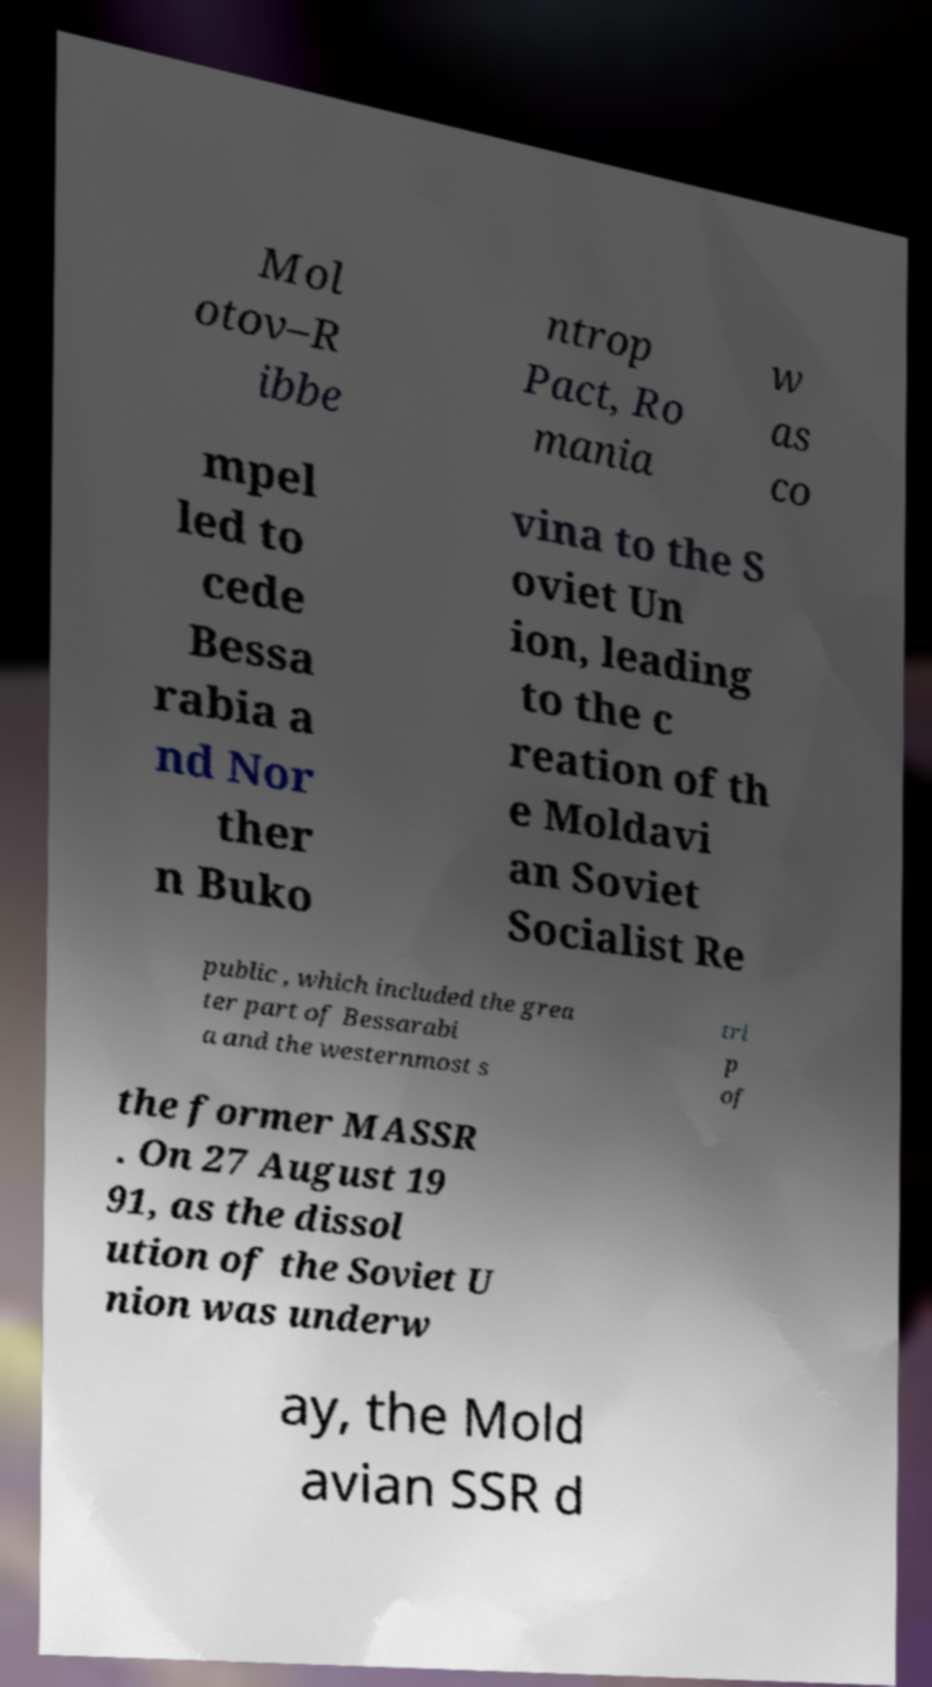There's text embedded in this image that I need extracted. Can you transcribe it verbatim? Mol otov–R ibbe ntrop Pact, Ro mania w as co mpel led to cede Bessa rabia a nd Nor ther n Buko vina to the S oviet Un ion, leading to the c reation of th e Moldavi an Soviet Socialist Re public , which included the grea ter part of Bessarabi a and the westernmost s tri p of the former MASSR . On 27 August 19 91, as the dissol ution of the Soviet U nion was underw ay, the Mold avian SSR d 